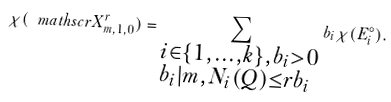<formula> <loc_0><loc_0><loc_500><loc_500>\chi ( \ m a t h s c r { X } ^ { r } _ { m , 1 , 0 } ) = \sum _ { \begin{subarray} { c } i \in \{ 1 , \dots , k \} , b _ { i } > 0 \\ b _ { i } | m , N _ { i } ( Q ) \leq r b _ { i } \end{subarray} } b _ { i } \chi ( E ^ { \circ } _ { i } ) .</formula> 